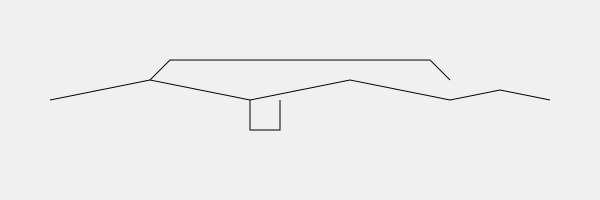Identify the naval aircraft model depicted in the silhouette above, which is prominently featured in Marc Liebman's Josh Haman series, particularly in missions involving carrier-based operations. To identify this aircraft, let's analyze its key features:

1. Long, slender fuselage: The aircraft has an elongated body, typical of high-speed jets.

2. Swept wings: The wings are angled backwards, indicating a supersonic design.

3. Twin tail: There are two vertical stabilizers at the rear, a common feature in many fighter jets.

4. Cockpit position: The cockpit is located towards the front of the aircraft.

5. Nose shape: The nose is slightly pointed, suggesting good aerodynamics.

These characteristics are consistent with the F-14 Tomcat, a carrier-based fighter aircraft that plays a significant role in Marc Liebman's Josh Haman series. The F-14 was the U.S. Navy's primary air superiority fighter and interceptor from the 1970s to the mid-2000s.

In the Josh Haman series, particularly in books like "Render Harmless" and "Forgotten," the F-14 Tomcat is often mentioned as part of carrier air wings and involved in various missions. Josh Haman, being a naval aviator, would be very familiar with this aircraft and its capabilities.
Answer: F-14 Tomcat 